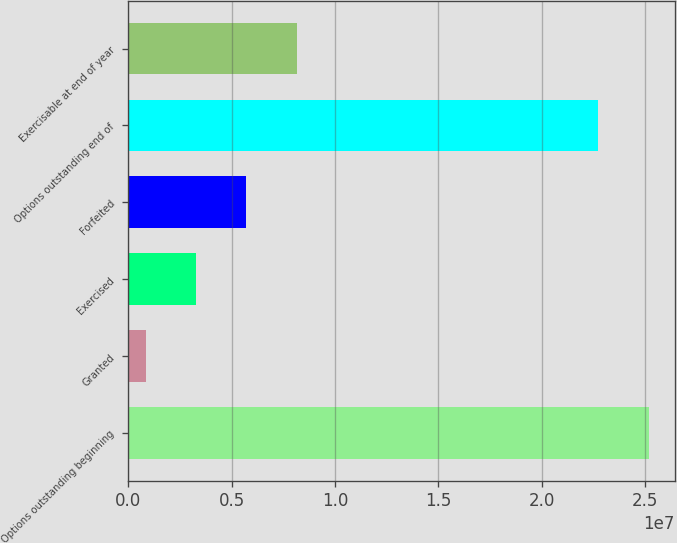Convert chart to OTSL. <chart><loc_0><loc_0><loc_500><loc_500><bar_chart><fcel>Options outstanding beginning<fcel>Granted<fcel>Exercised<fcel>Forfeited<fcel>Options outstanding end of<fcel>Exercisable at end of year<nl><fcel>2.51726e+07<fcel>867500<fcel>3.29254e+06<fcel>5.71758e+06<fcel>2.27476e+07<fcel>8.14262e+06<nl></chart> 